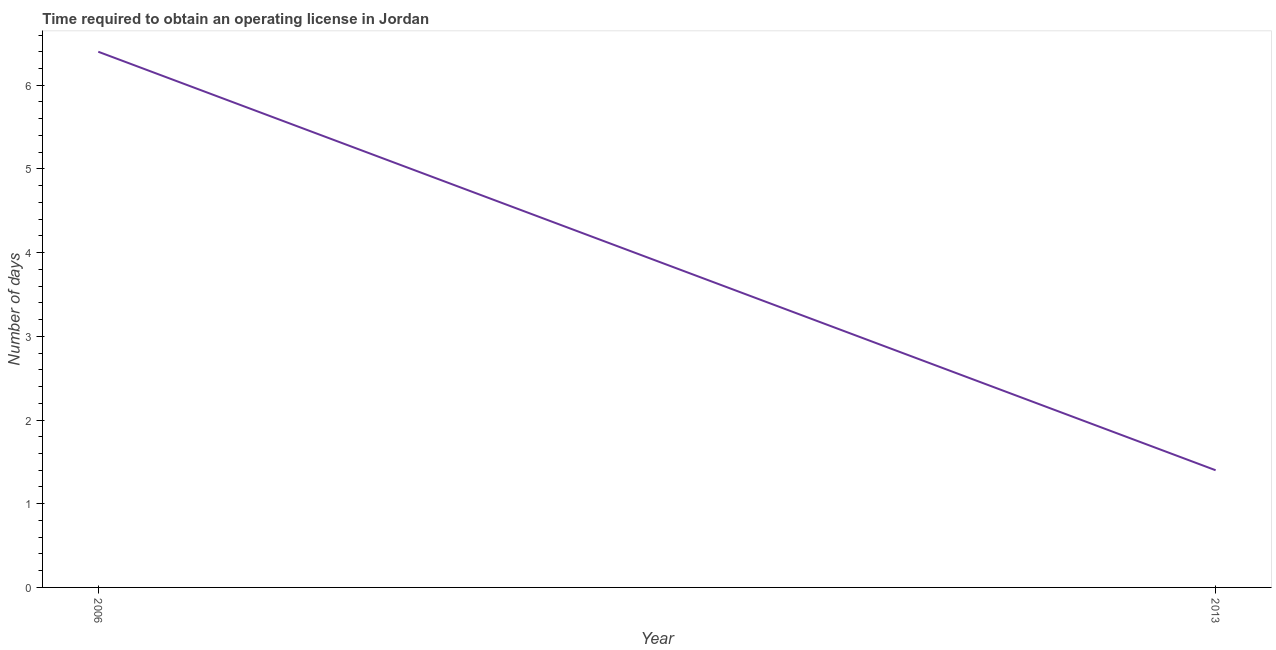Across all years, what is the maximum number of days to obtain operating license?
Your answer should be very brief. 6.4. Across all years, what is the minimum number of days to obtain operating license?
Provide a succinct answer. 1.4. What is the sum of the number of days to obtain operating license?
Provide a succinct answer. 7.8. What is the difference between the number of days to obtain operating license in 2006 and 2013?
Offer a very short reply. 5. What is the average number of days to obtain operating license per year?
Offer a very short reply. 3.9. What is the median number of days to obtain operating license?
Keep it short and to the point. 3.9. In how many years, is the number of days to obtain operating license greater than 1.8 days?
Provide a short and direct response. 1. What is the ratio of the number of days to obtain operating license in 2006 to that in 2013?
Offer a very short reply. 4.57. Does the number of days to obtain operating license monotonically increase over the years?
Offer a very short reply. No. How many years are there in the graph?
Offer a terse response. 2. Does the graph contain any zero values?
Provide a short and direct response. No. Does the graph contain grids?
Offer a very short reply. No. What is the title of the graph?
Your answer should be compact. Time required to obtain an operating license in Jordan. What is the label or title of the Y-axis?
Offer a terse response. Number of days. What is the Number of days in 2013?
Provide a succinct answer. 1.4. What is the difference between the Number of days in 2006 and 2013?
Give a very brief answer. 5. What is the ratio of the Number of days in 2006 to that in 2013?
Provide a short and direct response. 4.57. 